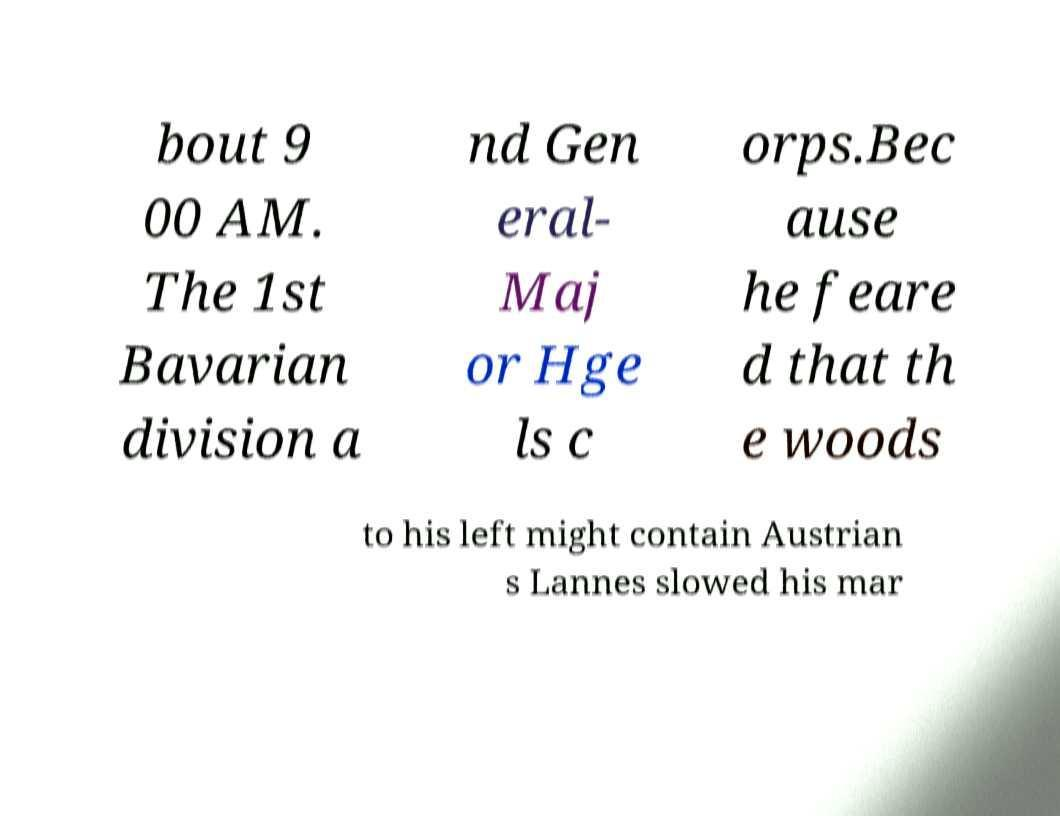Could you assist in decoding the text presented in this image and type it out clearly? bout 9 00 AM. The 1st Bavarian division a nd Gen eral- Maj or Hge ls c orps.Bec ause he feare d that th e woods to his left might contain Austrian s Lannes slowed his mar 